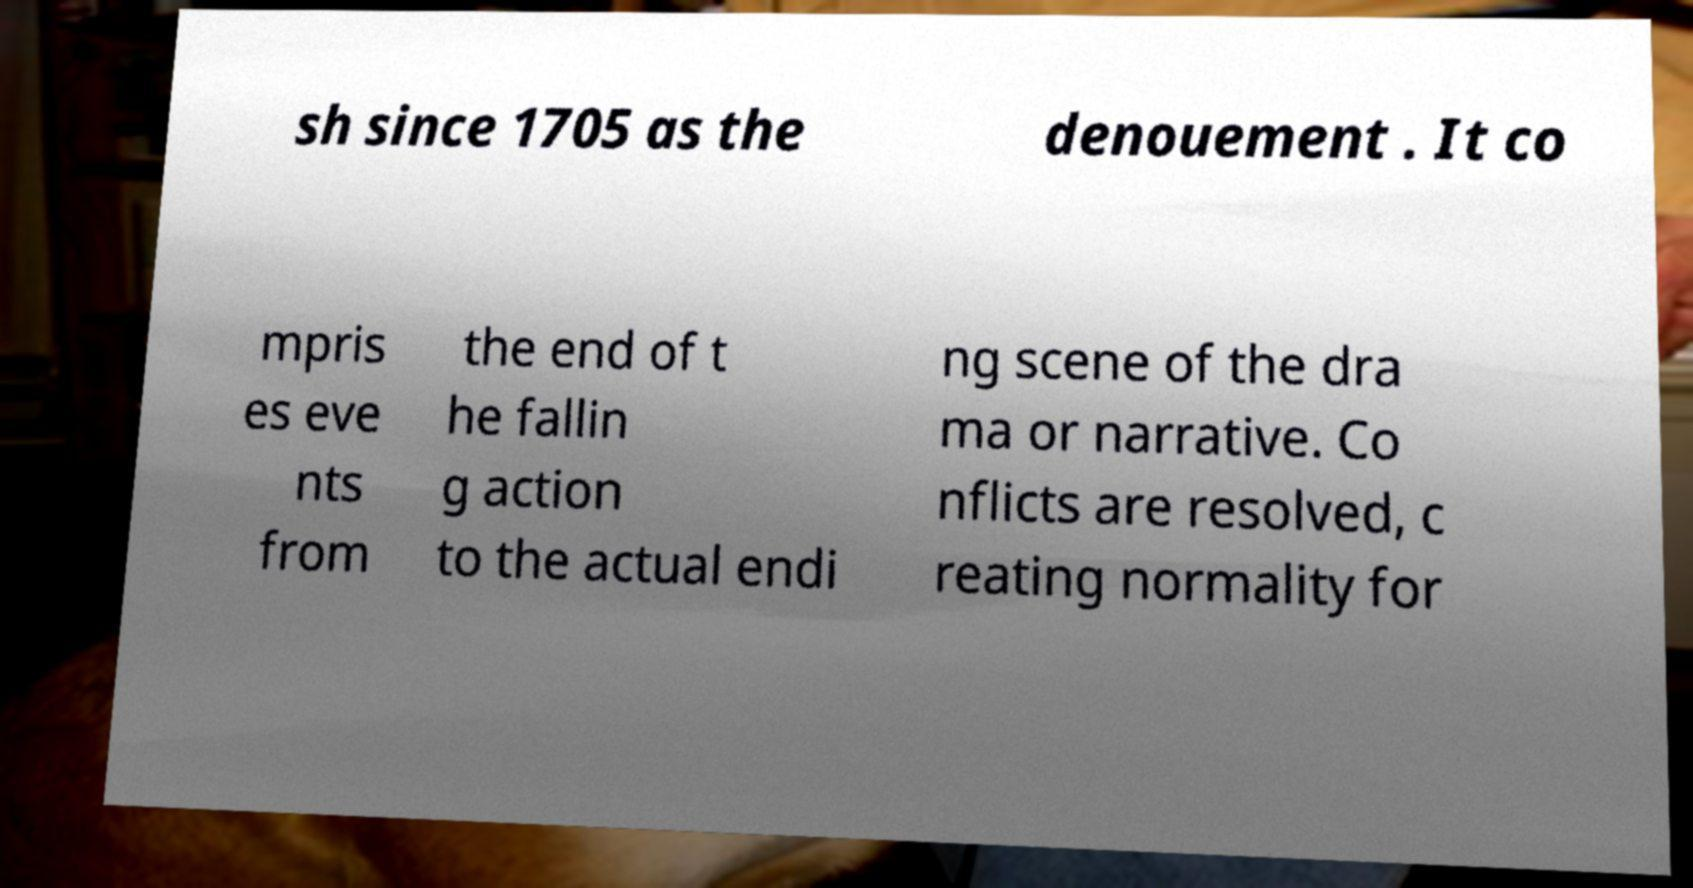Can you accurately transcribe the text from the provided image for me? sh since 1705 as the denouement . It co mpris es eve nts from the end of t he fallin g action to the actual endi ng scene of the dra ma or narrative. Co nflicts are resolved, c reating normality for 